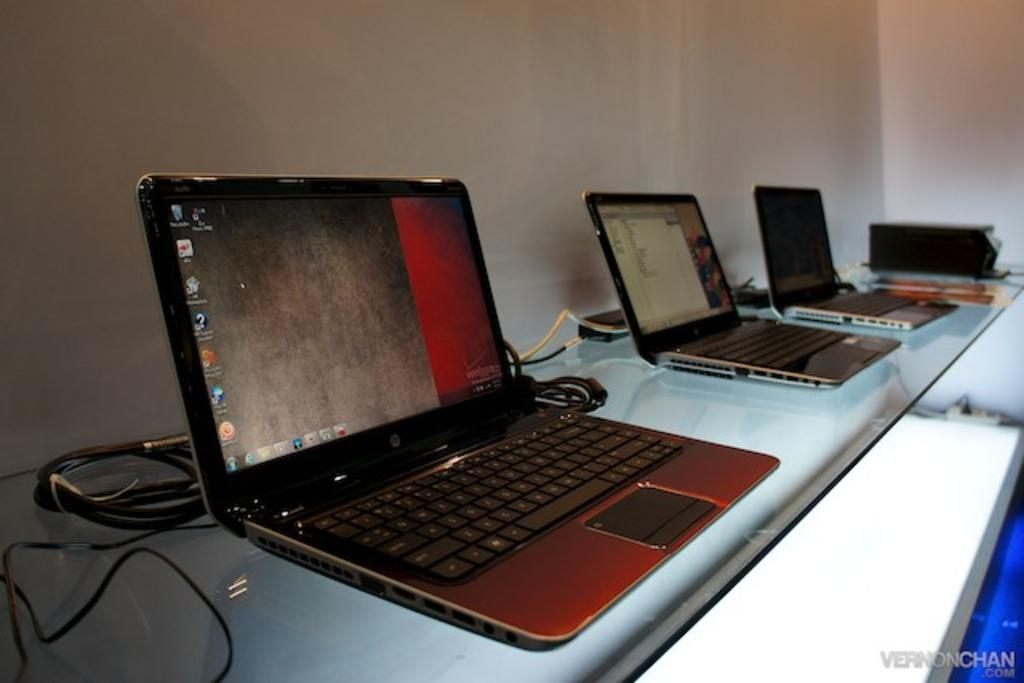What piece of furniture is present in the image? There is a desk in the image. What electronic devices are on the desk? There are three laptops on the desk. How are the laptops arranged on the desk? The laptops are placed side by side. What can be seen behind the laptops? There are wires behind the laptops. What is visible in the background of the image? There is a wall in the background of the image. Can you tell me how many snakes are slithering on the desk in the image? There are no snakes present in the image; it features a desk with three laptops and wires. What type of exchange is taking place between the laptops in the image? There is no exchange happening between the laptops in the image; they are simply placed side by side on the desk. 